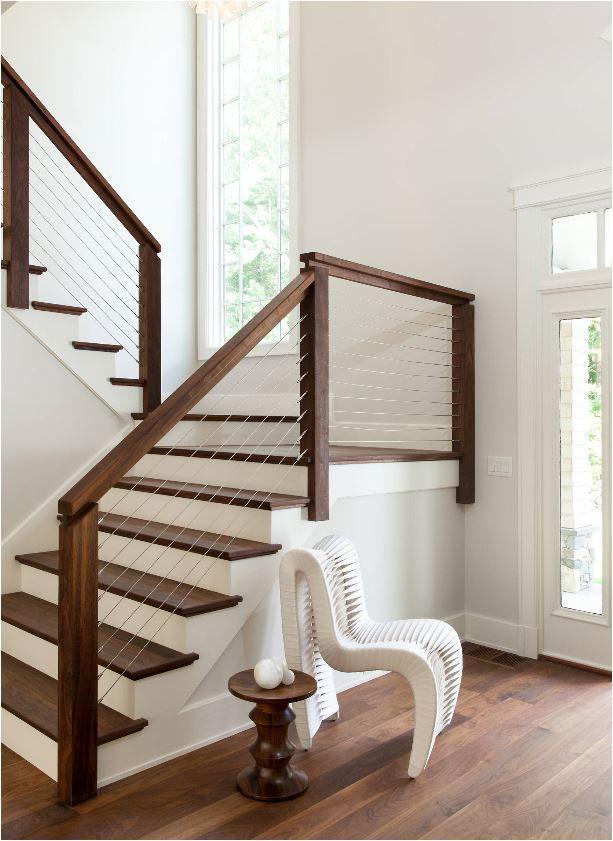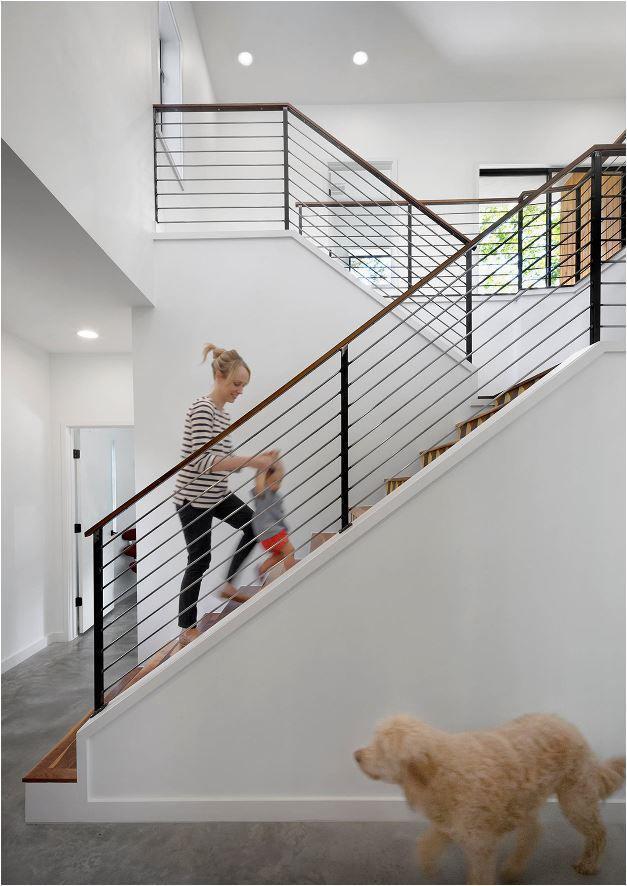The first image is the image on the left, the second image is the image on the right. Evaluate the accuracy of this statement regarding the images: "At least one staircase that combines brown wood steps with white paint starts from the lower left angling rightward, then turns sharply back to the left.". Is it true? Answer yes or no. Yes. 